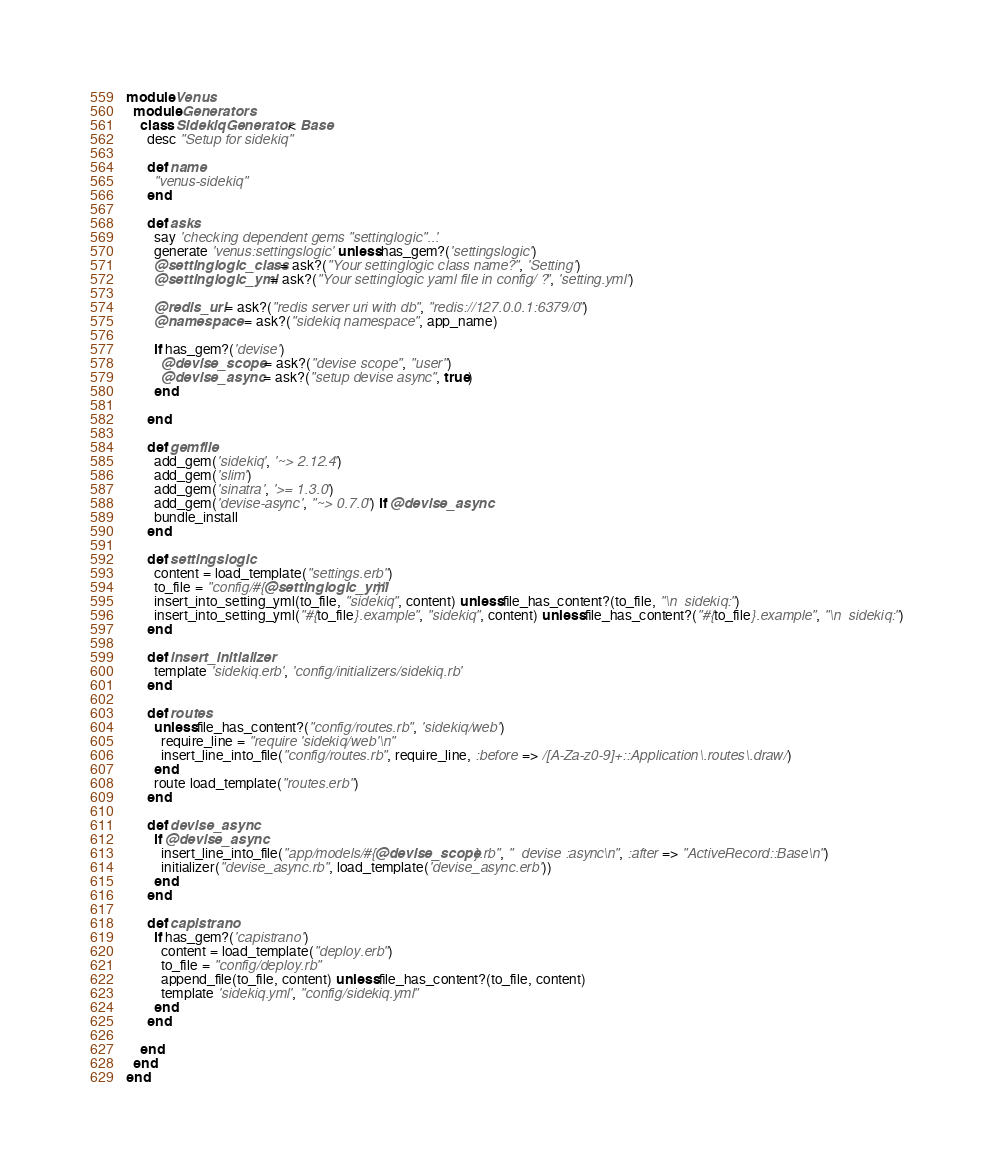<code> <loc_0><loc_0><loc_500><loc_500><_Ruby_>module Venus
  module Generators
    class SidekiqGenerator < Base
      desc "Setup for sidekiq"

      def name
        "venus-sidekiq"
      end

      def asks
        say 'checking dependent gems "settinglogic"...'
        generate 'venus:settingslogic' unless has_gem?('settingslogic')
        @settinglogic_class = ask?("Your settinglogic class name?", 'Setting')
        @settinglogic_yml = ask?("Your settinglogic yaml file in config/ ?", 'setting.yml')

        @redis_uri = ask?("redis server uri with db", "redis://127.0.0.1:6379/0")
        @namespace = ask?("sidekiq namespace", app_name)

        if has_gem?('devise')
          @devise_scope = ask?("devise scope", "user")
          @devise_async = ask?("setup devise async", true)
        end

      end

      def gemfile
        add_gem('sidekiq', '~> 2.12.4')
        add_gem('slim')
        add_gem('sinatra', '>= 1.3.0')
        add_gem('devise-async', "~> 0.7.0") if @devise_async
        bundle_install
      end

      def settingslogic
        content = load_template("settings.erb")
        to_file = "config/#{@settinglogic_yml}"
        insert_into_setting_yml(to_file, "sidekiq", content) unless file_has_content?(to_file, "\n  sidekiq:")
        insert_into_setting_yml("#{to_file}.example", "sidekiq", content) unless file_has_content?("#{to_file}.example", "\n  sidekiq:")
      end

      def insert_initializer
        template 'sidekiq.erb', 'config/initializers/sidekiq.rb'
      end

      def routes
        unless file_has_content?("config/routes.rb", 'sidekiq/web')
          require_line = "require 'sidekiq/web'\n"
          insert_line_into_file("config/routes.rb", require_line, :before => /[A-Za-z0-9]+::Application\.routes\.draw/)
        end
        route load_template("routes.erb")
      end

      def devise_async
        if @devise_async
          insert_line_into_file("app/models/#{@devise_scope}.rb", "  devise :async\n", :after => "ActiveRecord::Base\n")
          initializer("devise_async.rb", load_template('devise_async.erb'))
        end
      end

      def capistrano
        if has_gem?('capistrano')
          content = load_template("deploy.erb")
          to_file = "config/deploy.rb"
          append_file(to_file, content) unless file_has_content?(to_file, content)
          template 'sidekiq.yml', "config/sidekiq.yml"
        end
      end

    end
  end
end
</code> 